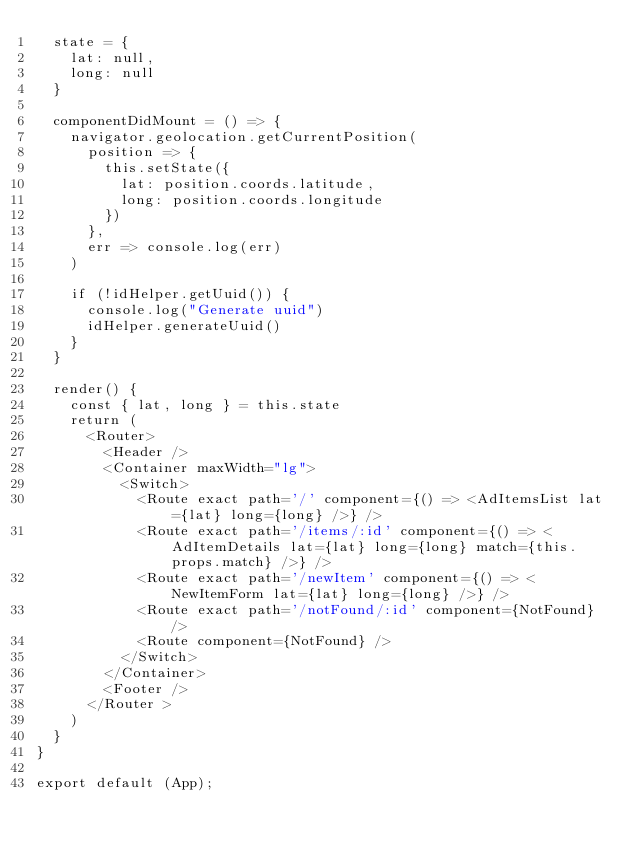<code> <loc_0><loc_0><loc_500><loc_500><_JavaScript_>  state = {
    lat: null,
    long: null
  }

  componentDidMount = () => {
    navigator.geolocation.getCurrentPosition(
      position => {
        this.setState({
          lat: position.coords.latitude,
          long: position.coords.longitude
        })
      },
      err => console.log(err)
    )

    if (!idHelper.getUuid()) {
      console.log("Generate uuid")
      idHelper.generateUuid()
    }
  }

  render() {
    const { lat, long } = this.state
    return (
      <Router>
        <Header />
        <Container maxWidth="lg">
          <Switch>
            <Route exact path='/' component={() => <AdItemsList lat={lat} long={long} />} />
            <Route exact path='/items/:id' component={() => <AdItemDetails lat={lat} long={long} match={this.props.match} />} />
            <Route exact path='/newItem' component={() => <NewItemForm lat={lat} long={long} />} />
            <Route exact path='/notFound/:id' component={NotFound} />
            <Route component={NotFound} />
          </Switch>
        </Container>
        <Footer />
      </Router >
    )
  }
}

export default (App);
</code> 